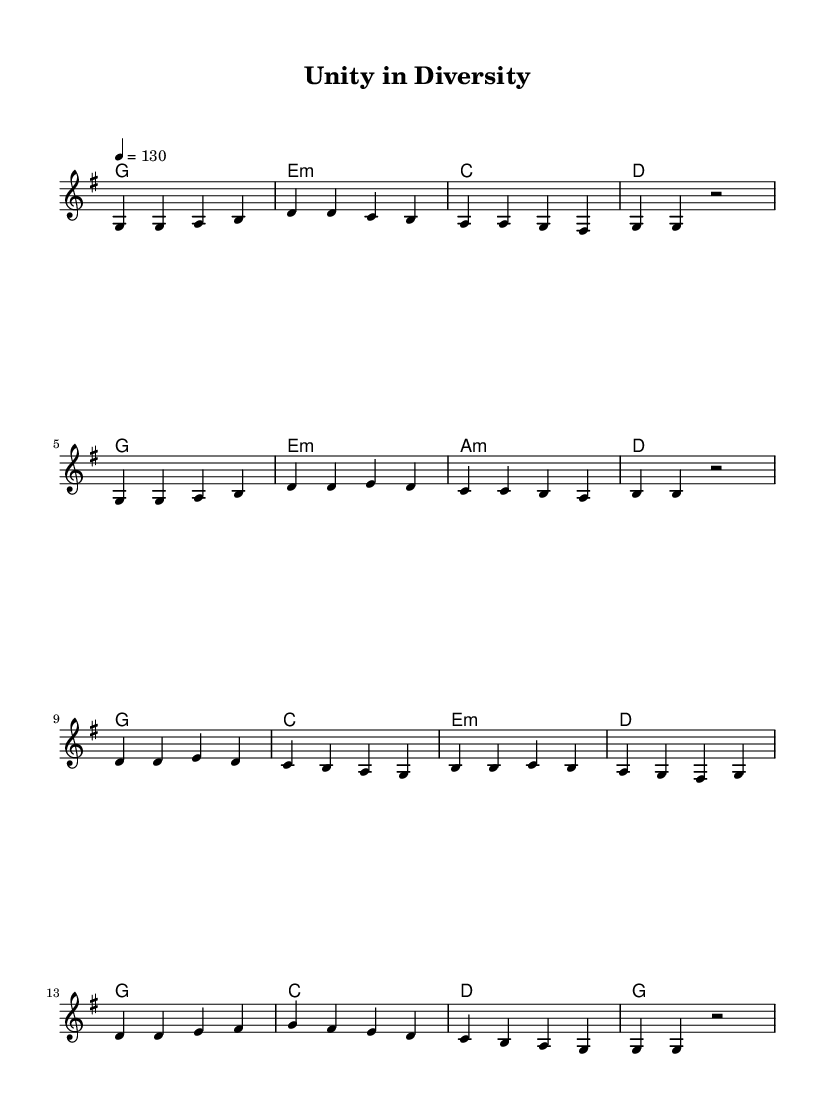What is the key signature of this music? The key signature is G major, which has one sharp (F#).
Answer: G major What is the time signature of this piece? The time signature is 4/4, indicating four beats per measure with a quarter note receiving one beat.
Answer: 4/4 What is the tempo marking for this piece? The tempo marking indicates a tempo of 130 beats per minute.
Answer: 130 How many measures are in the verse? The verse consists of four measures, as seen in the music notation section labeled 'Verse'.
Answer: 4 What is the first note of the chorus? The first note of the chorus is D, as indicated by the melody starting on the note D in the corresponding measure.
Answer: D What chord follows the first measure of the verse? The chord following the first measure of the verse is E minor, as indicated by the chord notation underneath the melody line.
Answer: E minor How many different chords are used in the chorus? There are four different chords used in the chorus as observed in the chord progression during that section.
Answer: 4 